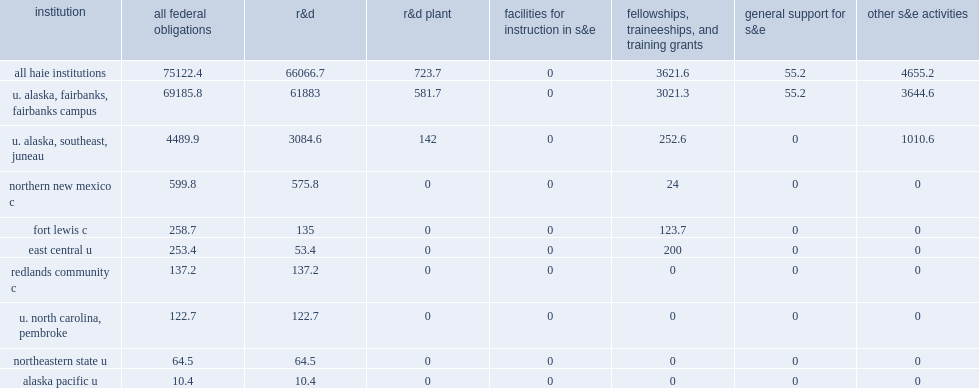What was the percent of total s&e support to haie institutions for r&d? 0.879454. What was the percent of total s&e support to haie institutions for other s&e activities? 0.061968. What was the percent of total s&e support to haie institutions for fttg? 0.048209. 